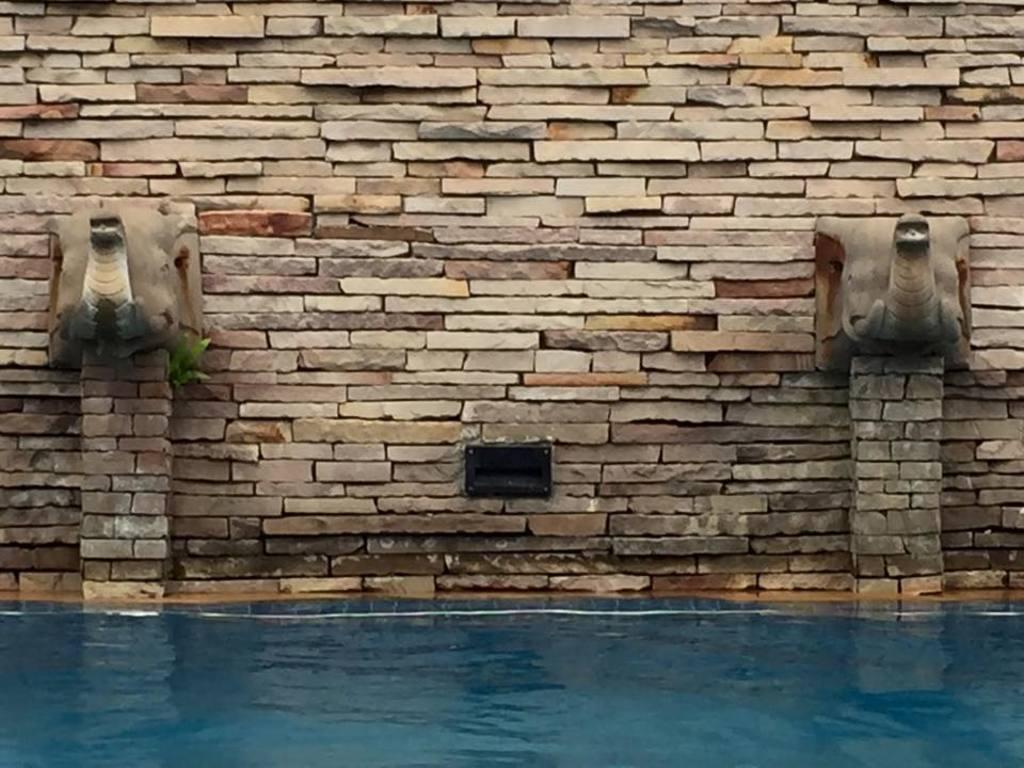What is present in the image that is related to water? There is water in the image. What structures can be seen in the image that involve water? There are fountains in the image. What type of architectural feature is visible in the image? There is a wall in the image. How many bikes are visible in the image? There are no bikes present in the image. What color are the eyes of the person in the image? There are no people or eyes visible in the image. 